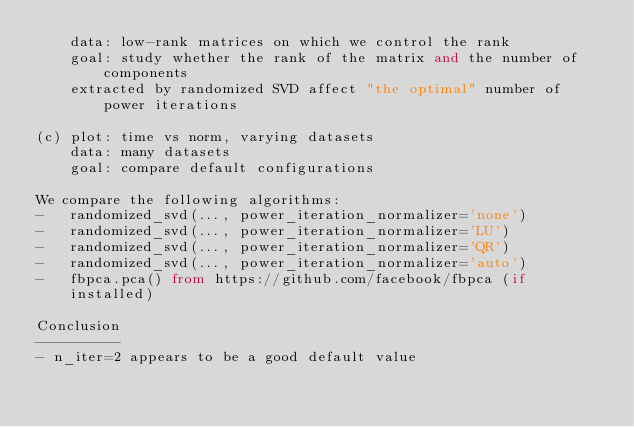Convert code to text. <code><loc_0><loc_0><loc_500><loc_500><_Python_>    data: low-rank matrices on which we control the rank
    goal: study whether the rank of the matrix and the number of components
    extracted by randomized SVD affect "the optimal" number of power iterations

(c) plot: time vs norm, varying datasets
    data: many datasets
    goal: compare default configurations

We compare the following algorithms:
-   randomized_svd(..., power_iteration_normalizer='none')
-   randomized_svd(..., power_iteration_normalizer='LU')
-   randomized_svd(..., power_iteration_normalizer='QR')
-   randomized_svd(..., power_iteration_normalizer='auto')
-   fbpca.pca() from https://github.com/facebook/fbpca (if installed)

Conclusion
----------
- n_iter=2 appears to be a good default value</code> 